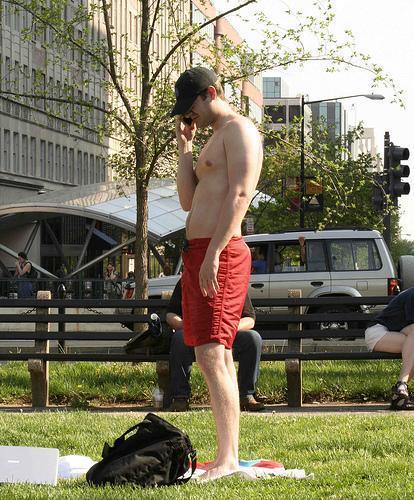How many shirtless men are there?
Give a very brief answer. 1. 